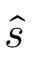<formula> <loc_0><loc_0><loc_500><loc_500>\hat { s }</formula> 